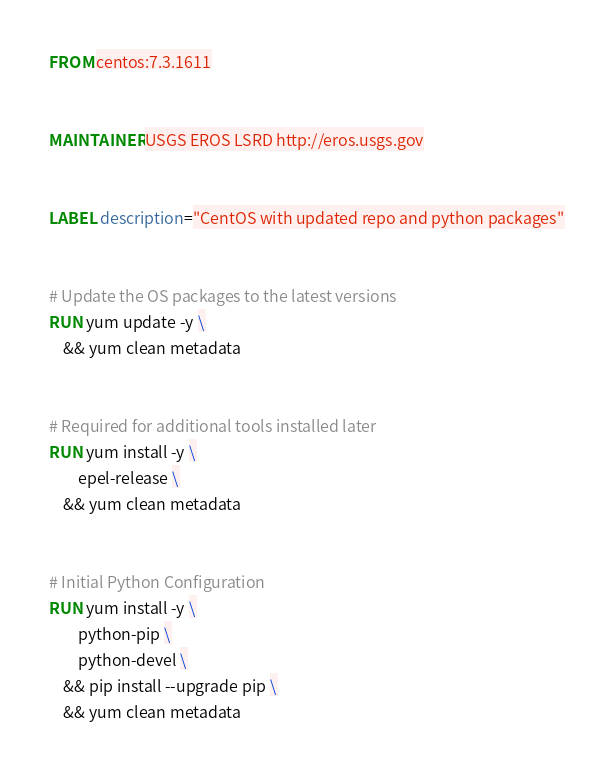Convert code to text. <code><loc_0><loc_0><loc_500><loc_500><_Dockerfile_>FROM centos:7.3.1611


MAINTAINER USGS EROS LSRD http://eros.usgs.gov


LABEL description="CentOS with updated repo and python packages"


# Update the OS packages to the latest versions
RUN yum update -y \
    && yum clean metadata


# Required for additional tools installed later
RUN yum install -y \
        epel-release \
    && yum clean metadata


# Initial Python Configuration
RUN yum install -y \
        python-pip \
        python-devel \
    && pip install --upgrade pip \
    && yum clean metadata
</code> 